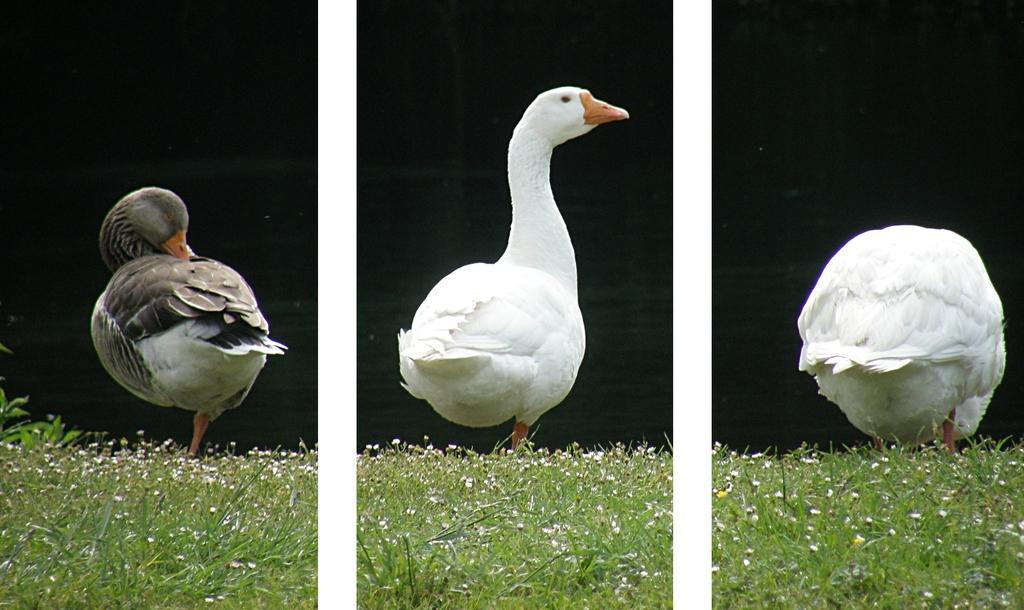Please provide a concise description of this image. This is a collage picture and in this picture we can see three birds standing on grass and in the background it is dark. 